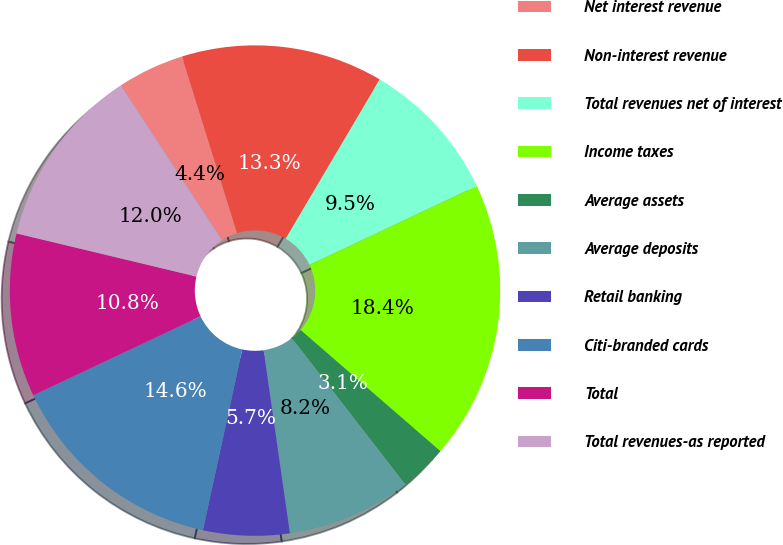Convert chart to OTSL. <chart><loc_0><loc_0><loc_500><loc_500><pie_chart><fcel>Net interest revenue<fcel>Non-interest revenue<fcel>Total revenues net of interest<fcel>Income taxes<fcel>Average assets<fcel>Average deposits<fcel>Retail banking<fcel>Citi-branded cards<fcel>Total<fcel>Total revenues-as reported<nl><fcel>4.41%<fcel>13.3%<fcel>9.49%<fcel>18.38%<fcel>3.14%<fcel>8.22%<fcel>5.68%<fcel>14.57%<fcel>10.76%<fcel>12.03%<nl></chart> 